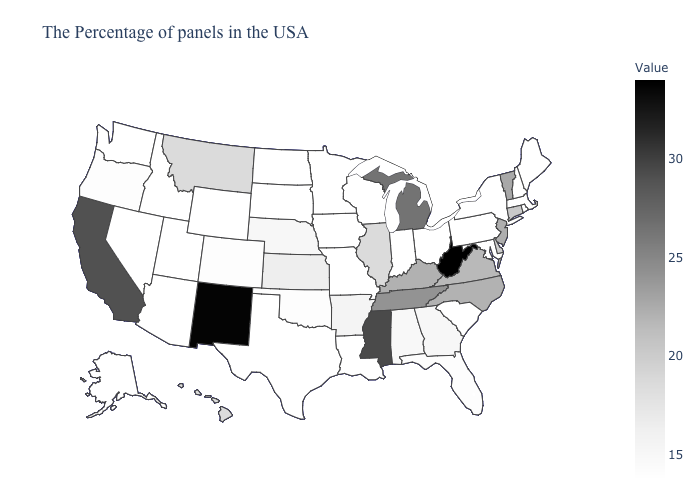Among the states that border Nebraska , which have the lowest value?
Short answer required. Missouri, Iowa, South Dakota, Wyoming. Does South Carolina have the lowest value in the USA?
Answer briefly. Yes. Among the states that border Idaho , does Montana have the lowest value?
Quick response, please. No. Which states have the lowest value in the USA?
Quick response, please. Maine, Massachusetts, New Hampshire, New York, Maryland, Pennsylvania, South Carolina, Ohio, Indiana, Wisconsin, Louisiana, Missouri, Minnesota, Iowa, Texas, South Dakota, North Dakota, Wyoming, Utah, Arizona, Idaho, Nevada, Washington, Alaska. Does the map have missing data?
Keep it brief. No. Among the states that border Nevada , which have the lowest value?
Concise answer only. Utah, Arizona, Idaho. Among the states that border Illinois , does Iowa have the highest value?
Answer briefly. No. Does Michigan have the lowest value in the MidWest?
Short answer required. No. 